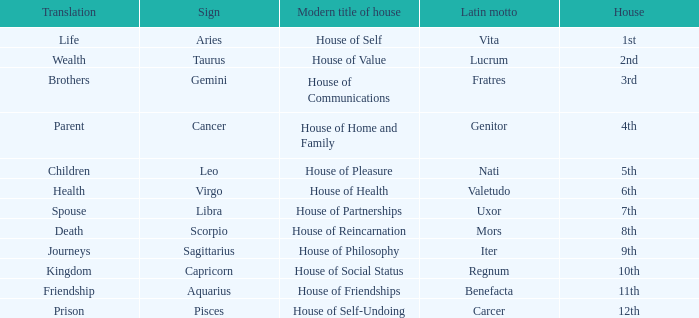What is the Latin motto of the sign that translates to spouse? Uxor. 